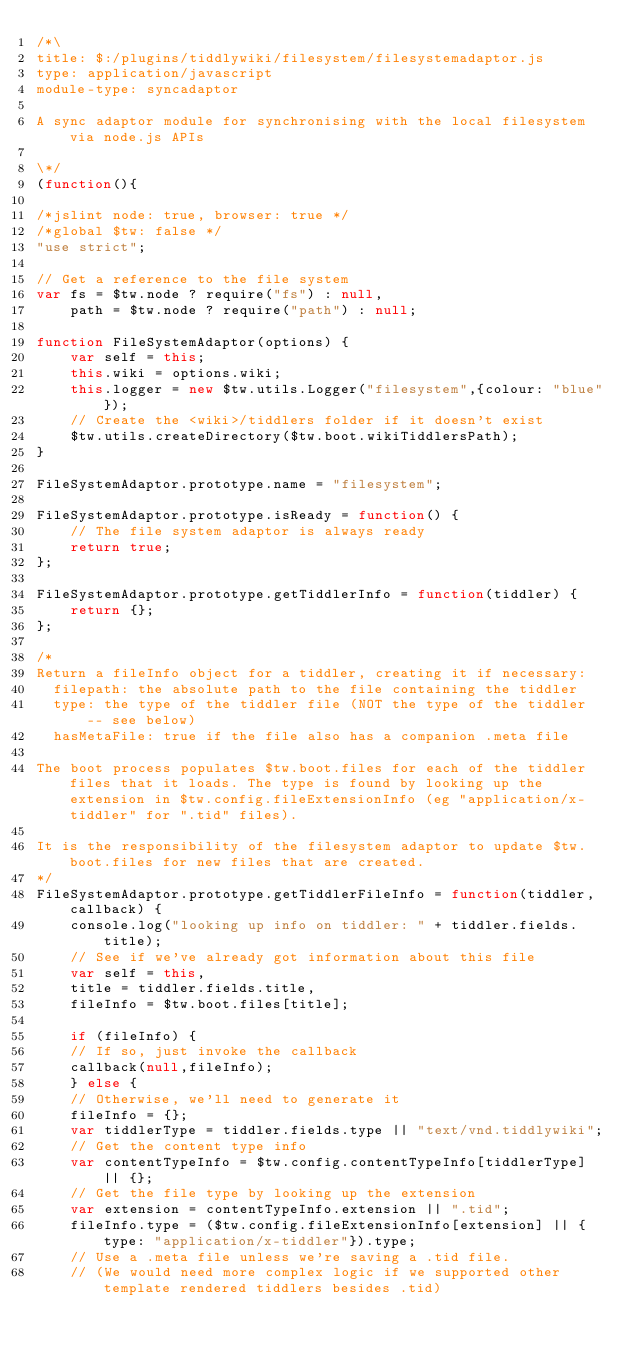Convert code to text. <code><loc_0><loc_0><loc_500><loc_500><_JavaScript_>/*\
title: $:/plugins/tiddlywiki/filesystem/filesystemadaptor.js
type: application/javascript
module-type: syncadaptor

A sync adaptor module for synchronising with the local filesystem via node.js APIs

\*/
(function(){

/*jslint node: true, browser: true */
/*global $tw: false */
"use strict";

// Get a reference to the file system
var fs = $tw.node ? require("fs") : null,
	path = $tw.node ? require("path") : null;

function FileSystemAdaptor(options) {
	var self = this;
	this.wiki = options.wiki;
	this.logger = new $tw.utils.Logger("filesystem",{colour: "blue"});
	// Create the <wiki>/tiddlers folder if it doesn't exist
	$tw.utils.createDirectory($tw.boot.wikiTiddlersPath);
}

FileSystemAdaptor.prototype.name = "filesystem";

FileSystemAdaptor.prototype.isReady = function() {
	// The file system adaptor is always ready
	return true;
};

FileSystemAdaptor.prototype.getTiddlerInfo = function(tiddler) {
	return {};
};

/*
Return a fileInfo object for a tiddler, creating it if necessary:
  filepath: the absolute path to the file containing the tiddler
  type: the type of the tiddler file (NOT the type of the tiddler -- see below)
  hasMetaFile: true if the file also has a companion .meta file

The boot process populates $tw.boot.files for each of the tiddler files that it loads. The type is found by looking up the extension in $tw.config.fileExtensionInfo (eg "application/x-tiddler" for ".tid" files).

It is the responsibility of the filesystem adaptor to update $tw.boot.files for new files that are created.
*/
FileSystemAdaptor.prototype.getTiddlerFileInfo = function(tiddler,callback) {
    console.log("looking up info on tiddler: " + tiddler.fields.title);
    // See if we've already got information about this file
    var self = this,
	title = tiddler.fields.title,
	fileInfo = $tw.boot.files[title];

    if (fileInfo) {
	// If so, just invoke the callback
	callback(null,fileInfo);
    } else {
	// Otherwise, we'll need to generate it
	fileInfo = {};
	var tiddlerType = tiddler.fields.type || "text/vnd.tiddlywiki";
	// Get the content type info
	var contentTypeInfo = $tw.config.contentTypeInfo[tiddlerType] || {};
	// Get the file type by looking up the extension
	var extension = contentTypeInfo.extension || ".tid";
	fileInfo.type = ($tw.config.fileExtensionInfo[extension] || {type: "application/x-tiddler"}).type;
	// Use a .meta file unless we're saving a .tid file.
	// (We would need more complex logic if we supported other template rendered tiddlers besides .tid)</code> 